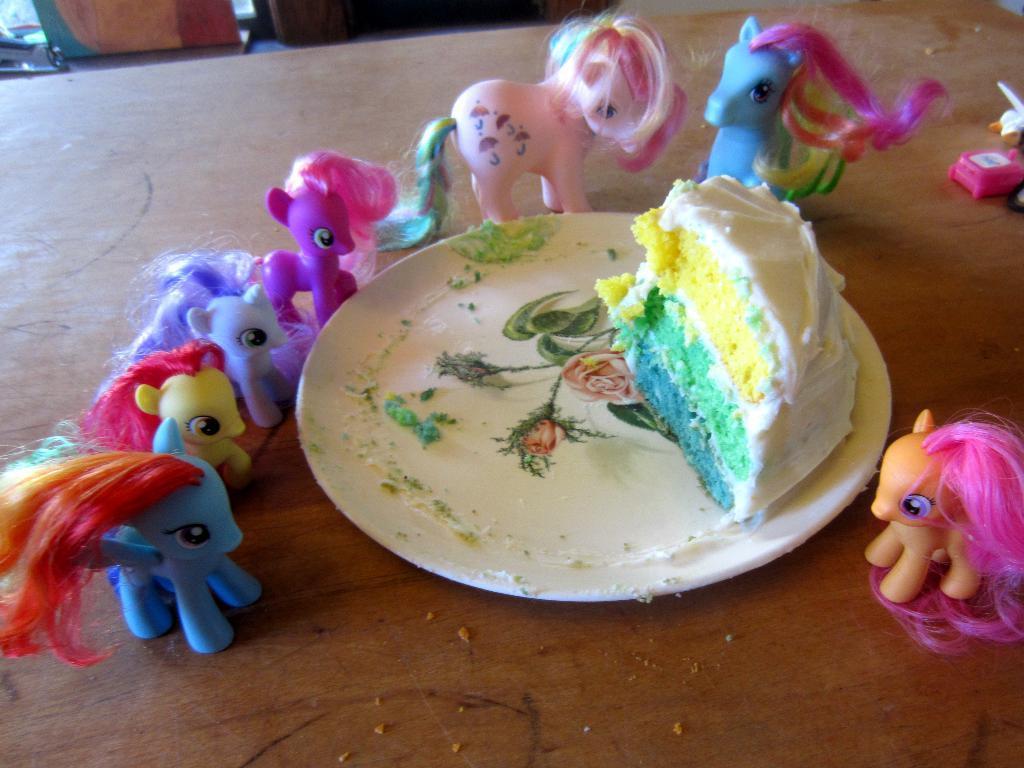How would you summarize this image in a sentence or two? In the picture we can see a table on it, we can see a plate which is white in color with some cake slice on it with three layers like green, yellow and blue and around the plate we can see some dolls are places which are in a different color. 